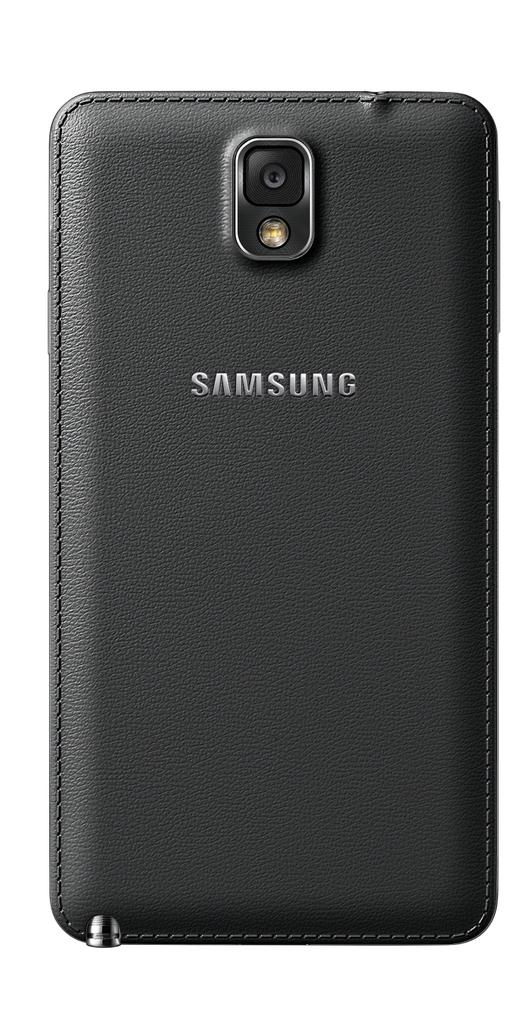What brand is this phone?
Keep it short and to the point. Samsung. Is this a samsung phone protector?
Ensure brevity in your answer.  Yes. 